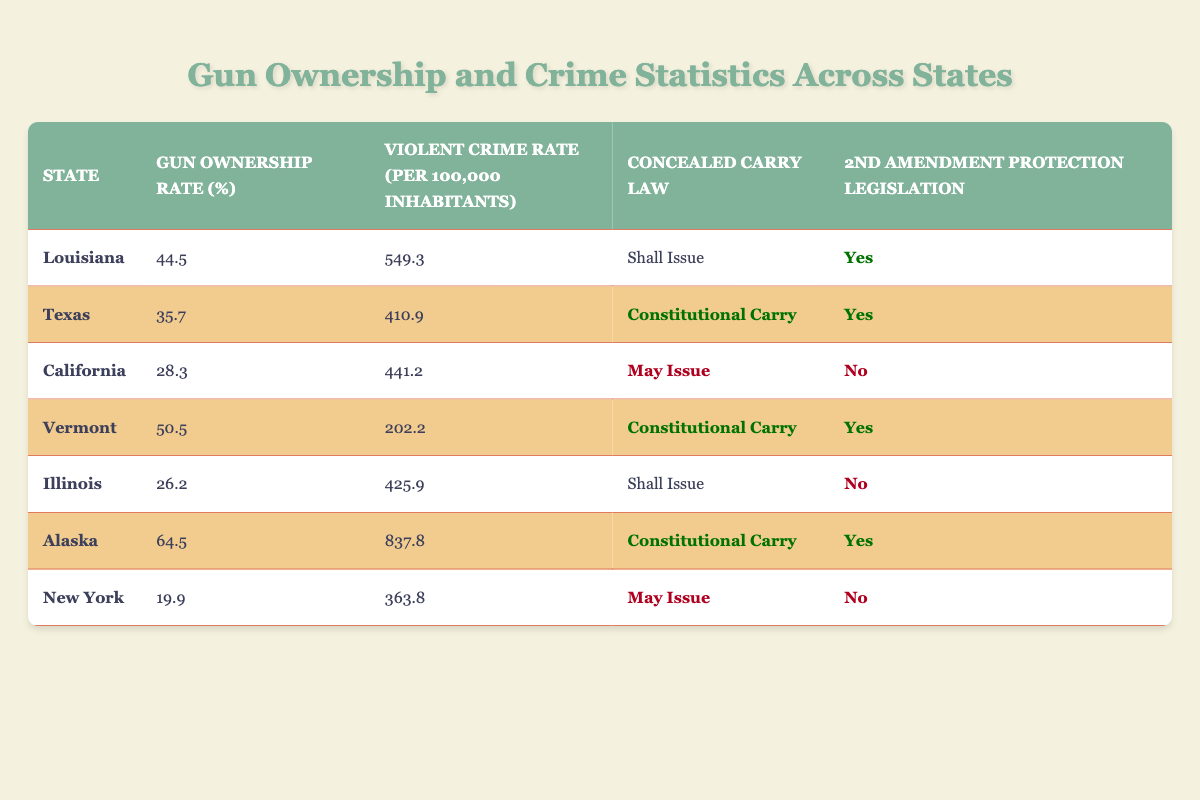What is the gun ownership rate in Louisiana? The table clearly lists Louisiana's gun ownership rate in the respective column, which is 44.5%.
Answer: 44.5% Which state has the highest violent crime rate? By examining the "Violent Crime Rate" column, Alaska displays the highest number at 837.8 per 100,000 inhabitants.
Answer: Alaska Do both Texas and Louisiana have 2nd Amendment Protection Legislation? Checking the "2nd Amendment Protection Legislation" column shows that both Texas and Louisiana have marked "Yes" for this legislation.
Answer: Yes What is the average gun ownership rate for states with Constitutional Carry? The states with Constitutional Carry are Texas (35.7), Vermont (50.5), and Alaska (64.5). Their total is 150.7, and dividing by the number of states (3) gives an average of 50.2.
Answer: 50.2 Is the violent crime rate in New York lower than that in California? The table shows New York's violent crime rate is 363.8, while California's is higher at 441.2. Therefore, New York has a lower rate.
Answer: Yes What is the difference in gun ownership rates between Vermont and California? Vermont's gun ownership rate is 50.5% and California's is 28.3%. The difference is 50.5 - 28.3 = 22.2%.
Answer: 22.2% Are there any states that have a gun ownership rate above 50% and a violent crime rate under 300? By examining the table, no state exceeds 50% gun ownership with a violent crime rate below 300. The highest is Vermont (50.5%), whose crime rate of 202.2 is the only low rate, but both conditions are not met.
Answer: No Which state has the lowest gun ownership rate and what is its violent crime rate? Illinois has the lowest gun ownership rate at 26.2%, with its violent crime rate listed as 425.9.
Answer: 26.2%, 425.9 How many states in the table have a 'Shall Issue' concealed carry law? Checking the "Concealed Carry Law" column, Louisiana and Illinois are the only two states categorized under "Shall Issue."
Answer: 2 